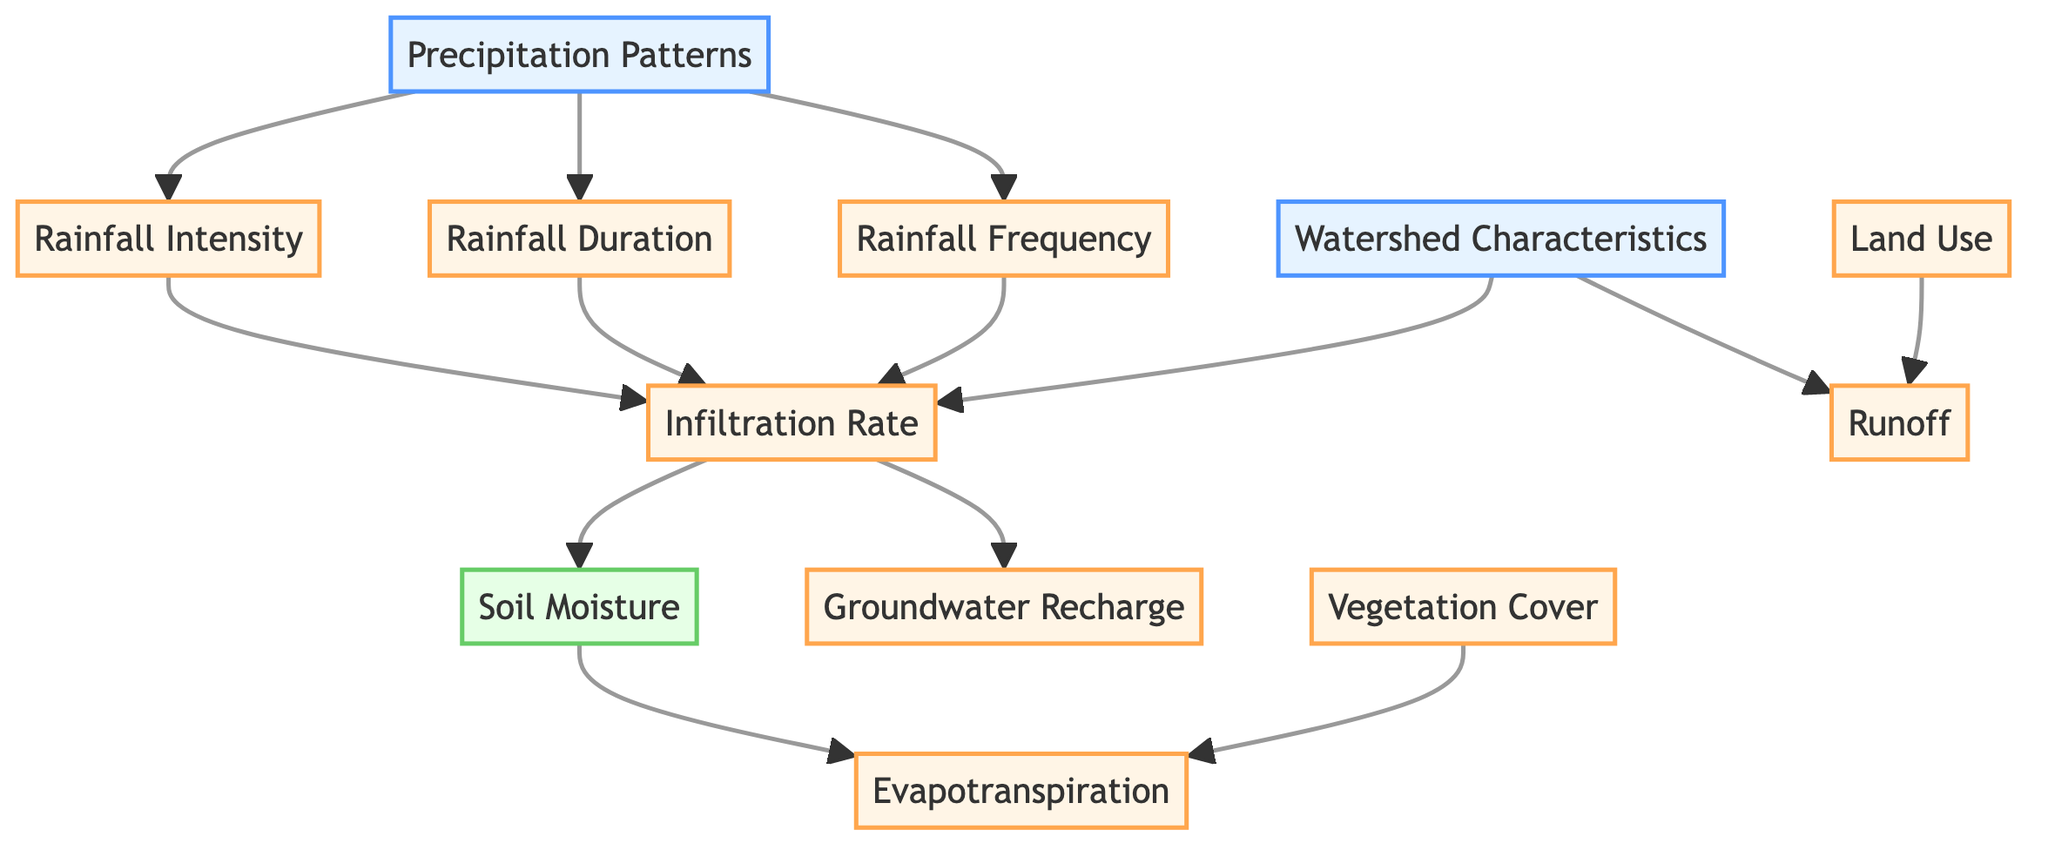What are the intermediate nodes in the diagram? The intermediate nodes are derived from the connections in the diagram, which include Rainfall Intensity, Rainfall Duration, Rainfall Frequency, Infiltration Rate, Runoff, Evapotranspiration, Groundwater Recharge, Vegetation Cover, and Land Use.
Answer: Rainfall Intensity, Rainfall Duration, Rainfall Frequency, Infiltration Rate, Runoff, Evapotranspiration, Groundwater Recharge, Vegetation Cover, Land Use How many edges are connected to the Soil Moisture node? The Soil Moisture node has two incoming edges: one from Infiltration Rate and one from the output of the Soil Moisture node to Evapotranspiration. Therefore, it connects to two distinct edges.
Answer: 2 What is the primary input in this diagram? The primary inputs, based on the diagram's categorization, are Precipitation Patterns and Watershed Characteristics, which directly influence the intermediate nodes.
Answer: Precipitation Patterns, Watershed Characteristics Which node directly affects groundwater recharge? Groundwater Recharge is directly influenced by Infiltration Rate, which is determined by factors such as Rainfall Intensity, Rainfall Duration, and Rainfall Frequency.
Answer: Infiltration Rate What is the relationship between rainfall intensity and soil moisture? Rainfall Intensity contributes to Infiltration Rate, which has a direct pathway to Soil Moisture; thus, changes in Rainfall Intensity affect soil moisture levels.
Answer: Infiltration Rate What effect does vegetation cover have in the diagram? Vegetation Cover directly influences the rate of Evapotranspiration, indicating the role of plants in the water cycle within the watershed hydrology network.
Answer: Evapotranspiration How many input nodes are there in total? In the diagram, there are two input nodes: Precipitation Patterns and Watershed Characteristics. Therefore, the total count of input nodes is two.
Answer: 2 Which edge connects the Rainfall Duration node? The Rainfall Duration node connects to Infiltration Rate, which makes it critical in determining how the moisture enters the soil and affects soil moisture levels.
Answer: Infiltration Rate 